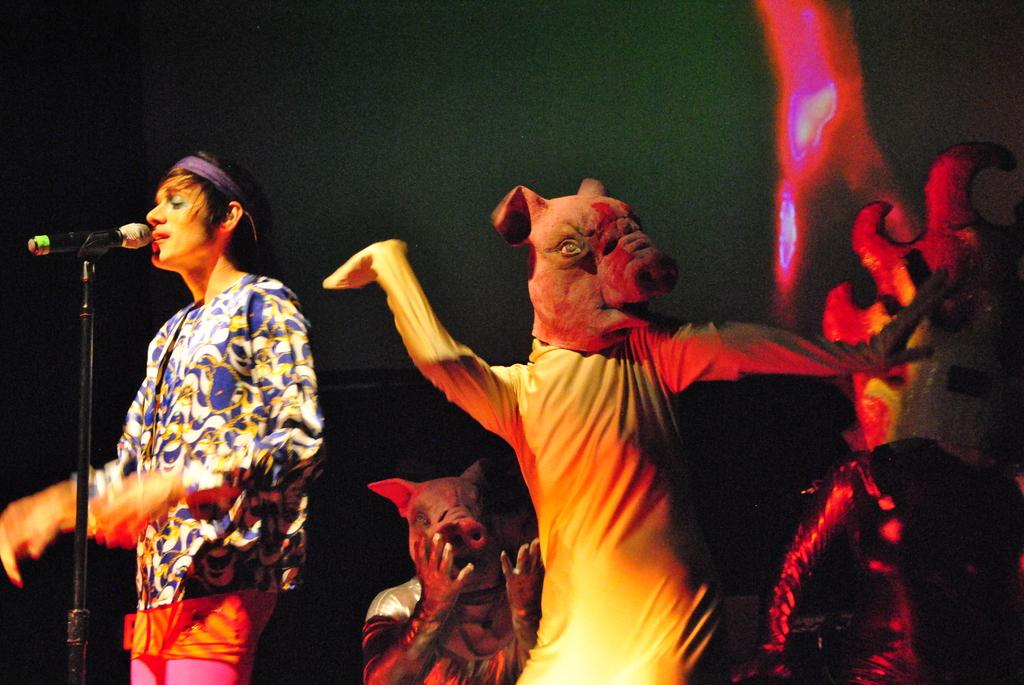What is the person on the left side of the image doing? The person is singing on a microphone. What can be seen on the right side of the image? There are mascots on the right side of the image. What type of toothpaste is the person using while singing on the microphone? There is no toothpaste present in the image, and the person is not using any toothpaste while singing on the microphone. Can you tell me how many grandmothers are visible in the image? There is no grandmother present in the image. 